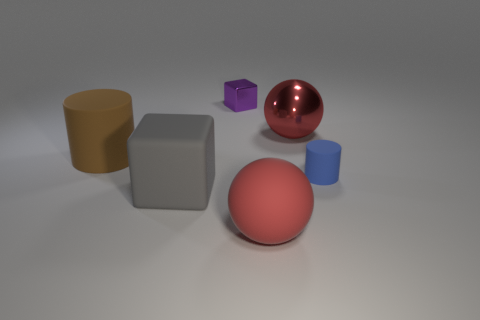Add 2 small cylinders. How many objects exist? 8 Subtract all blocks. How many objects are left? 4 Subtract 1 brown cylinders. How many objects are left? 5 Subtract all small cyan matte objects. Subtract all large gray blocks. How many objects are left? 5 Add 2 brown rubber things. How many brown rubber things are left? 3 Add 6 brown matte cylinders. How many brown matte cylinders exist? 7 